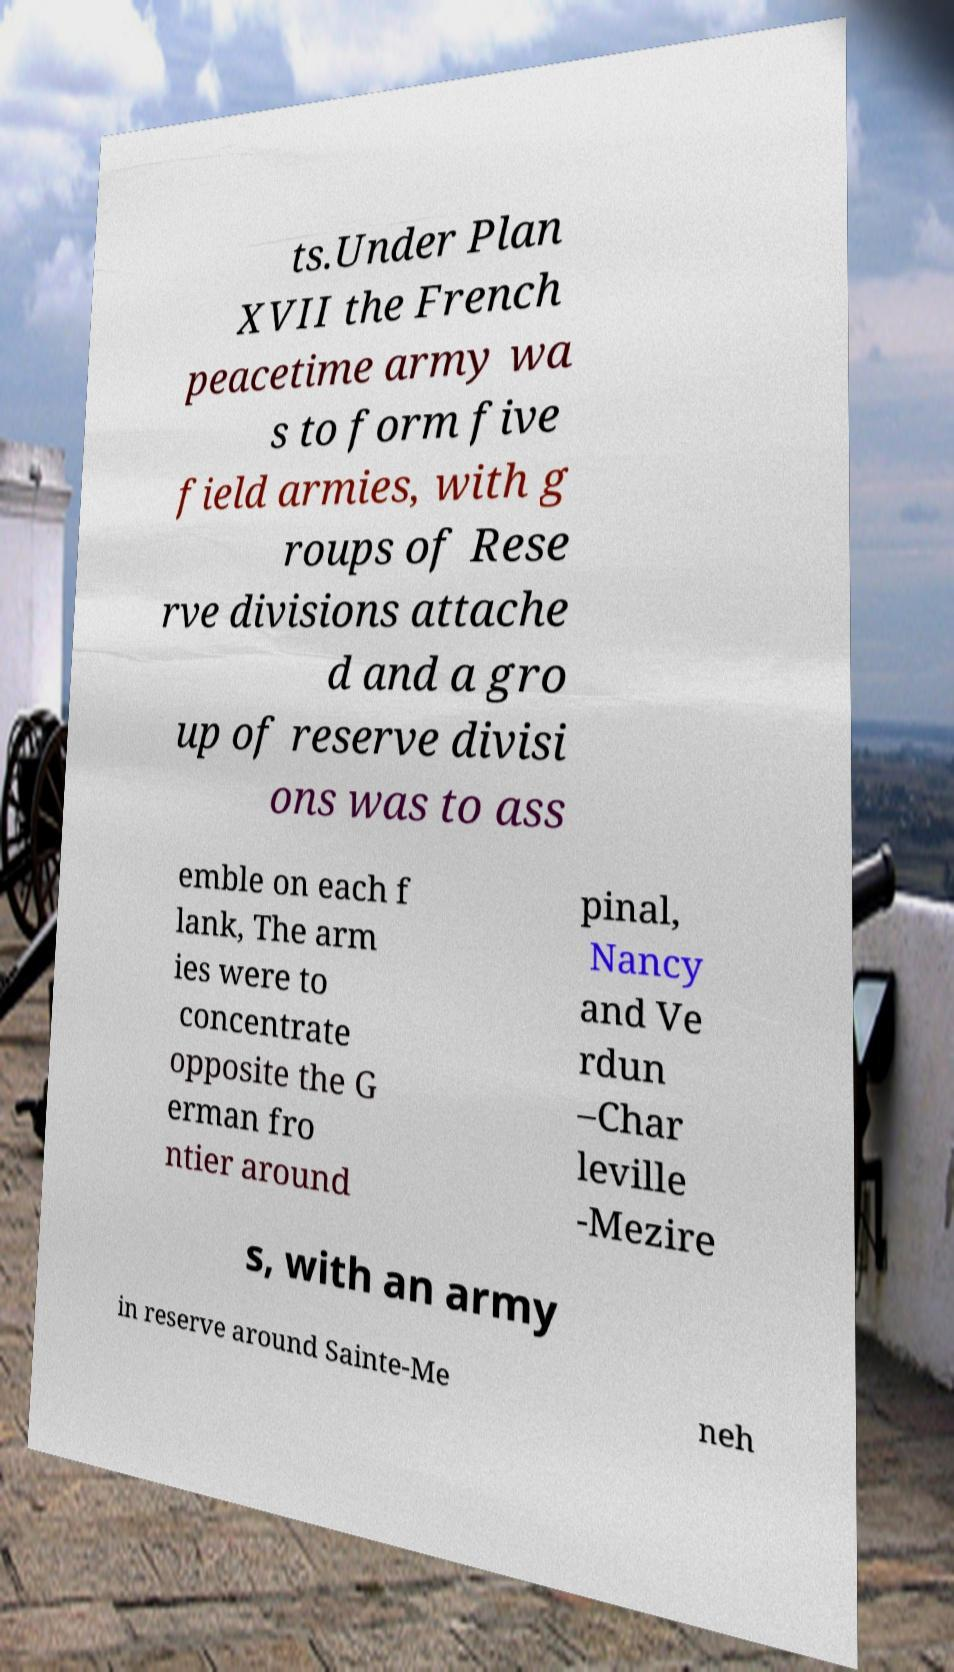Could you assist in decoding the text presented in this image and type it out clearly? ts.Under Plan XVII the French peacetime army wa s to form five field armies, with g roups of Rese rve divisions attache d and a gro up of reserve divisi ons was to ass emble on each f lank, The arm ies were to concentrate opposite the G erman fro ntier around pinal, Nancy and Ve rdun –Char leville -Mezire s, with an army in reserve around Sainte-Me neh 